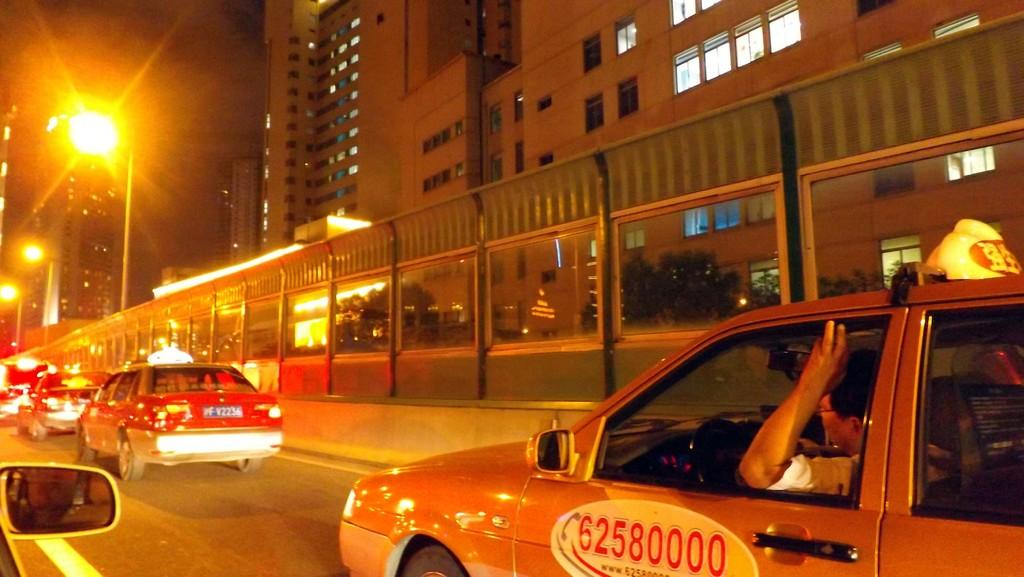Provide a one-sentence caption for the provided image. a taxi with phone number 62580000 lit up by a street lamp. 